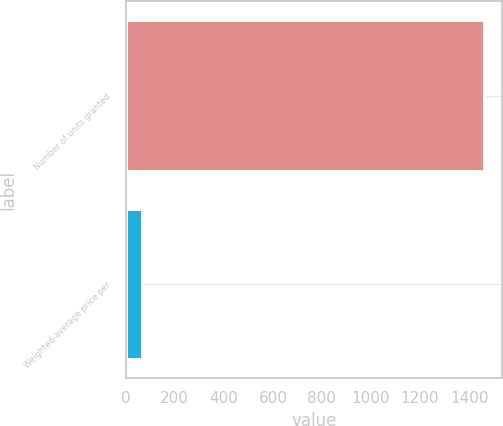Convert chart to OTSL. <chart><loc_0><loc_0><loc_500><loc_500><bar_chart><fcel>Number of units granted<fcel>Weighted-average price per<nl><fcel>1462.3<fcel>67.01<nl></chart> 